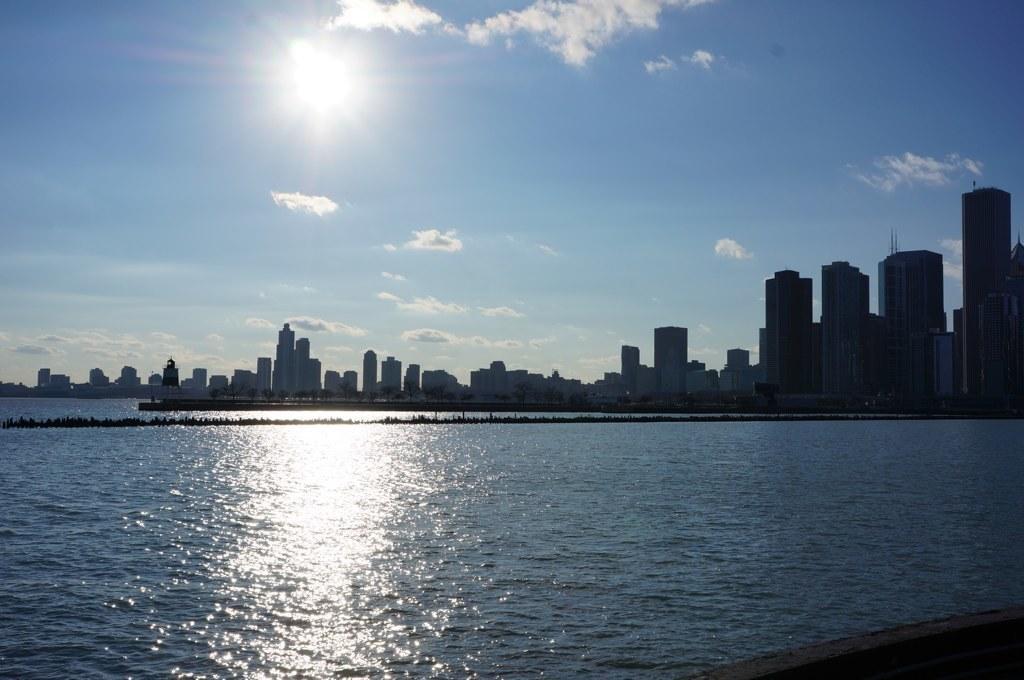How would you summarize this image in a sentence or two? In this picture we can see water and in the background there are building, trees, sky with clouds. 